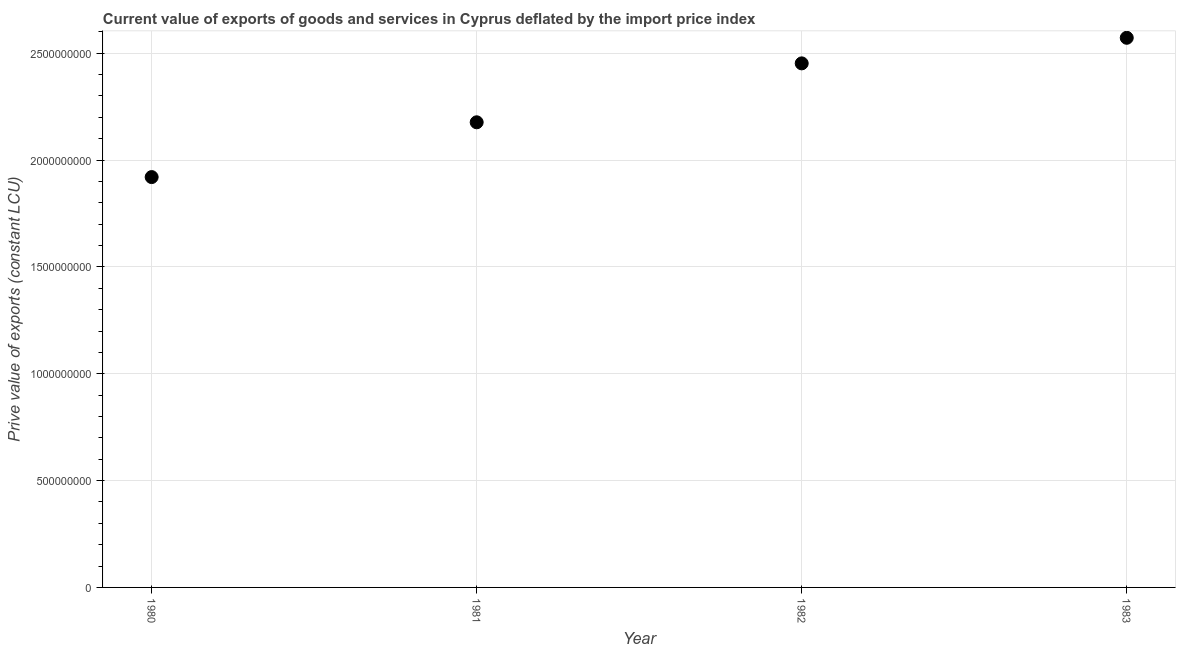What is the price value of exports in 1982?
Provide a succinct answer. 2.45e+09. Across all years, what is the maximum price value of exports?
Provide a succinct answer. 2.57e+09. Across all years, what is the minimum price value of exports?
Keep it short and to the point. 1.92e+09. In which year was the price value of exports maximum?
Give a very brief answer. 1983. What is the sum of the price value of exports?
Offer a very short reply. 9.12e+09. What is the difference between the price value of exports in 1980 and 1981?
Your answer should be very brief. -2.56e+08. What is the average price value of exports per year?
Offer a very short reply. 2.28e+09. What is the median price value of exports?
Ensure brevity in your answer.  2.31e+09. What is the ratio of the price value of exports in 1980 to that in 1981?
Give a very brief answer. 0.88. Is the difference between the price value of exports in 1980 and 1981 greater than the difference between any two years?
Offer a very short reply. No. What is the difference between the highest and the second highest price value of exports?
Your answer should be very brief. 1.20e+08. What is the difference between the highest and the lowest price value of exports?
Your response must be concise. 6.52e+08. In how many years, is the price value of exports greater than the average price value of exports taken over all years?
Ensure brevity in your answer.  2. How many dotlines are there?
Offer a terse response. 1. Are the values on the major ticks of Y-axis written in scientific E-notation?
Provide a short and direct response. No. What is the title of the graph?
Make the answer very short. Current value of exports of goods and services in Cyprus deflated by the import price index. What is the label or title of the X-axis?
Provide a succinct answer. Year. What is the label or title of the Y-axis?
Provide a succinct answer. Prive value of exports (constant LCU). What is the Prive value of exports (constant LCU) in 1980?
Ensure brevity in your answer.  1.92e+09. What is the Prive value of exports (constant LCU) in 1981?
Offer a terse response. 2.18e+09. What is the Prive value of exports (constant LCU) in 1982?
Your answer should be very brief. 2.45e+09. What is the Prive value of exports (constant LCU) in 1983?
Offer a very short reply. 2.57e+09. What is the difference between the Prive value of exports (constant LCU) in 1980 and 1981?
Provide a short and direct response. -2.56e+08. What is the difference between the Prive value of exports (constant LCU) in 1980 and 1982?
Make the answer very short. -5.32e+08. What is the difference between the Prive value of exports (constant LCU) in 1980 and 1983?
Keep it short and to the point. -6.52e+08. What is the difference between the Prive value of exports (constant LCU) in 1981 and 1982?
Offer a terse response. -2.76e+08. What is the difference between the Prive value of exports (constant LCU) in 1981 and 1983?
Your answer should be very brief. -3.95e+08. What is the difference between the Prive value of exports (constant LCU) in 1982 and 1983?
Offer a terse response. -1.20e+08. What is the ratio of the Prive value of exports (constant LCU) in 1980 to that in 1981?
Give a very brief answer. 0.88. What is the ratio of the Prive value of exports (constant LCU) in 1980 to that in 1982?
Your answer should be compact. 0.78. What is the ratio of the Prive value of exports (constant LCU) in 1980 to that in 1983?
Keep it short and to the point. 0.75. What is the ratio of the Prive value of exports (constant LCU) in 1981 to that in 1982?
Provide a short and direct response. 0.89. What is the ratio of the Prive value of exports (constant LCU) in 1981 to that in 1983?
Keep it short and to the point. 0.85. What is the ratio of the Prive value of exports (constant LCU) in 1982 to that in 1983?
Make the answer very short. 0.95. 